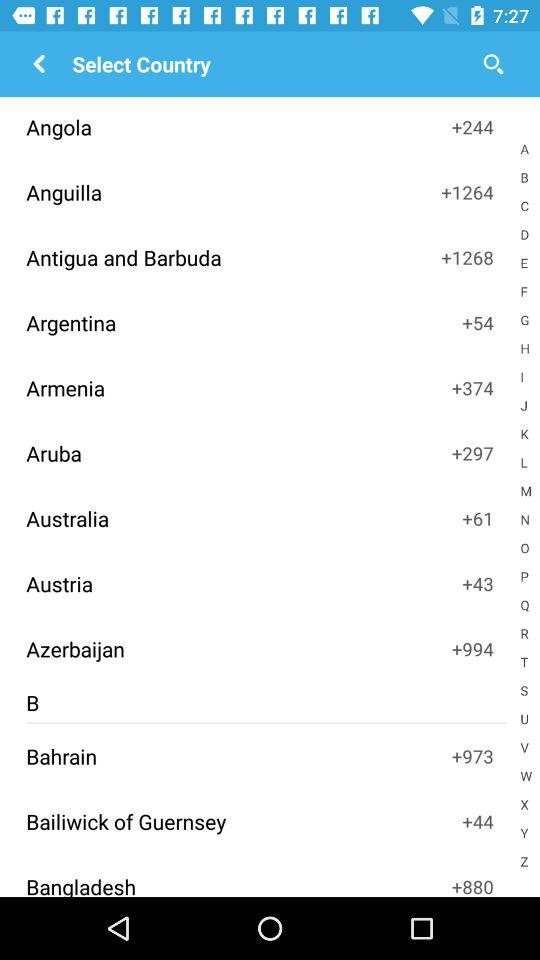Which country has the +61 code? The country is Australia. 